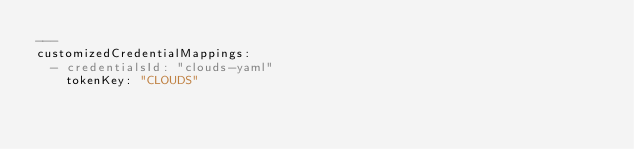<code> <loc_0><loc_0><loc_500><loc_500><_YAML_>---
customizedCredentialMappings:
  - credentialsId: "clouds-yaml"
    tokenKey: "CLOUDS"
</code> 